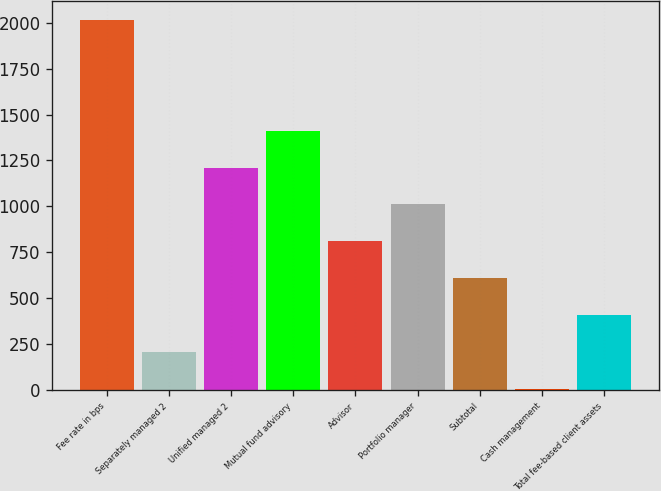Convert chart. <chart><loc_0><loc_0><loc_500><loc_500><bar_chart><fcel>Fee rate in bps<fcel>Separately managed 2<fcel>Unified managed 2<fcel>Mutual fund advisory<fcel>Advisor<fcel>Portfolio manager<fcel>Subtotal<fcel>Cash management<fcel>Total fee-based client assets<nl><fcel>2015<fcel>206.9<fcel>1211.4<fcel>1412.3<fcel>809.6<fcel>1010.5<fcel>608.7<fcel>6<fcel>407.8<nl></chart> 